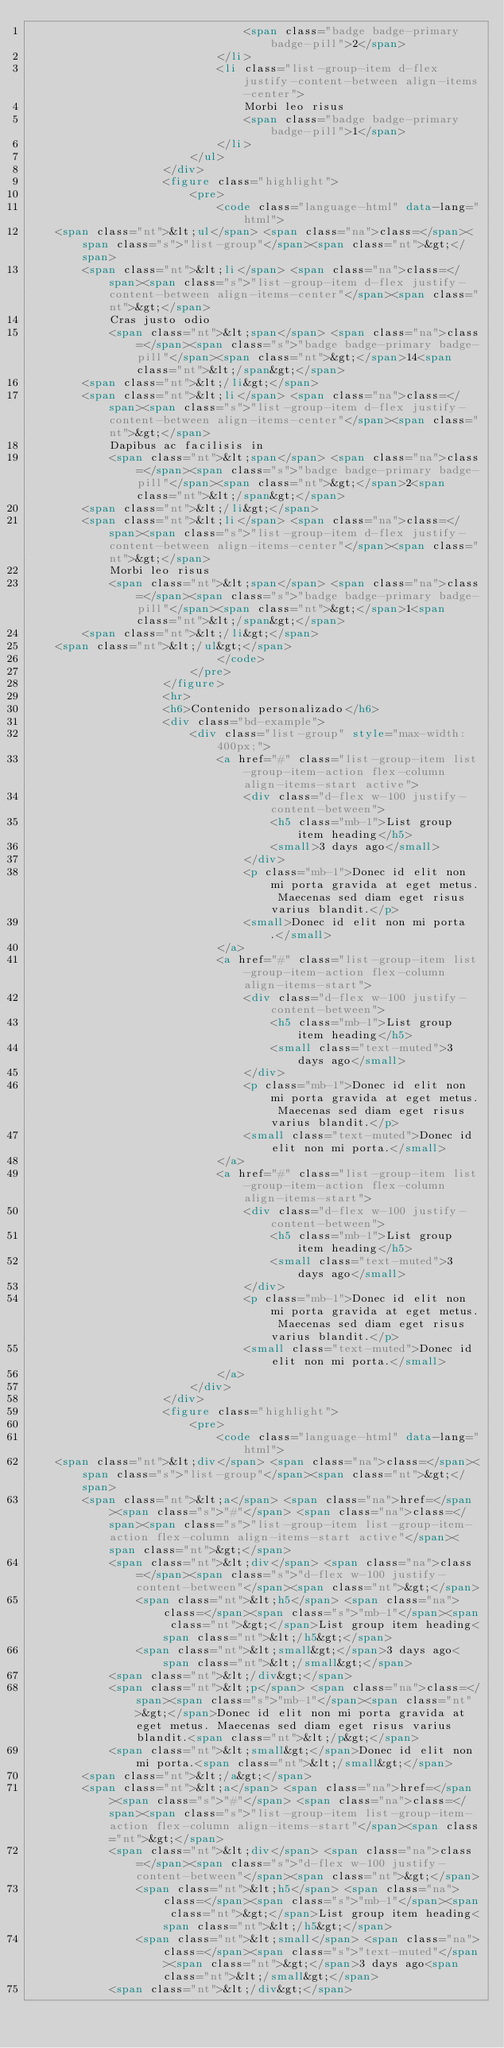<code> <loc_0><loc_0><loc_500><loc_500><_HTML_>                                <span class="badge badge-primary badge-pill">2</span>
                            </li>
                            <li class="list-group-item d-flex justify-content-between align-items-center">
                                Morbi leo risus
                                <span class="badge badge-primary badge-pill">1</span>
                            </li>
                        </ul>
                    </div>
                    <figure class="highlight">
                        <pre>
                            <code class="language-html" data-lang="html">
    <span class="nt">&lt;ul</span> <span class="na">class=</span><span class="s">"list-group"</span><span class="nt">&gt;</span>
        <span class="nt">&lt;li</span> <span class="na">class=</span><span class="s">"list-group-item d-flex justify-content-between align-items-center"</span><span class="nt">&gt;</span>
            Cras justo odio
            <span class="nt">&lt;span</span> <span class="na">class=</span><span class="s">"badge badge-primary badge-pill"</span><span class="nt">&gt;</span>14<span class="nt">&lt;/span&gt;</span>
        <span class="nt">&lt;/li&gt;</span>
        <span class="nt">&lt;li</span> <span class="na">class=</span><span class="s">"list-group-item d-flex justify-content-between align-items-center"</span><span class="nt">&gt;</span>
            Dapibus ac facilisis in
            <span class="nt">&lt;span</span> <span class="na">class=</span><span class="s">"badge badge-primary badge-pill"</span><span class="nt">&gt;</span>2<span class="nt">&lt;/span&gt;</span>
        <span class="nt">&lt;/li&gt;</span>
        <span class="nt">&lt;li</span> <span class="na">class=</span><span class="s">"list-group-item d-flex justify-content-between align-items-center"</span><span class="nt">&gt;</span>
            Morbi leo risus
            <span class="nt">&lt;span</span> <span class="na">class=</span><span class="s">"badge badge-primary badge-pill"</span><span class="nt">&gt;</span>1<span class="nt">&lt;/span&gt;</span>
        <span class="nt">&lt;/li&gt;</span>
    <span class="nt">&lt;/ul&gt;</span>
                            </code>
                        </pre>
                    </figure>
                    <hr>
                    <h6>Contenido personalizado</h6>
                    <div class="bd-example">
                        <div class="list-group" style="max-width: 400px;">
                            <a href="#" class="list-group-item list-group-item-action flex-column align-items-start active">
                                <div class="d-flex w-100 justify-content-between">
                                    <h5 class="mb-1">List group item heading</h5>
                                    <small>3 days ago</small>
                                </div>
                                <p class="mb-1">Donec id elit non mi porta gravida at eget metus. Maecenas sed diam eget risus varius blandit.</p>
                                <small>Donec id elit non mi porta.</small>
                            </a>
                            <a href="#" class="list-group-item list-group-item-action flex-column align-items-start">
                                <div class="d-flex w-100 justify-content-between">
                                    <h5 class="mb-1">List group item heading</h5>
                                    <small class="text-muted">3 days ago</small>
                                </div>
                                <p class="mb-1">Donec id elit non mi porta gravida at eget metus. Maecenas sed diam eget risus varius blandit.</p>
                                <small class="text-muted">Donec id elit non mi porta.</small>
                            </a>
                            <a href="#" class="list-group-item list-group-item-action flex-column align-items-start">
                                <div class="d-flex w-100 justify-content-between">
                                    <h5 class="mb-1">List group item heading</h5>
                                    <small class="text-muted">3 days ago</small>
                                </div>
                                <p class="mb-1">Donec id elit non mi porta gravida at eget metus. Maecenas sed diam eget risus varius blandit.</p>
                                <small class="text-muted">Donec id elit non mi porta.</small>
                            </a>
                        </div>
                    </div>
                    <figure class="highlight">
                        <pre>
                            <code class="language-html" data-lang="html">
    <span class="nt">&lt;div</span> <span class="na">class=</span><span class="s">"list-group"</span><span class="nt">&gt;</span>
        <span class="nt">&lt;a</span> <span class="na">href=</span><span class="s">"#"</span> <span class="na">class=</span><span class="s">"list-group-item list-group-item-action flex-column align-items-start active"</span><span class="nt">&gt;</span>
            <span class="nt">&lt;div</span> <span class="na">class=</span><span class="s">"d-flex w-100 justify-content-between"</span><span class="nt">&gt;</span>
                <span class="nt">&lt;h5</span> <span class="na">class=</span><span class="s">"mb-1"</span><span class="nt">&gt;</span>List group item heading<span class="nt">&lt;/h5&gt;</span>
                <span class="nt">&lt;small&gt;</span>3 days ago<span class="nt">&lt;/small&gt;</span>
            <span class="nt">&lt;/div&gt;</span>
            <span class="nt">&lt;p</span> <span class="na">class=</span><span class="s">"mb-1"</span><span class="nt">&gt;</span>Donec id elit non mi porta gravida at eget metus. Maecenas sed diam eget risus varius blandit.<span class="nt">&lt;/p&gt;</span>
            <span class="nt">&lt;small&gt;</span>Donec id elit non mi porta.<span class="nt">&lt;/small&gt;</span>
        <span class="nt">&lt;/a&gt;</span>
        <span class="nt">&lt;a</span> <span class="na">href=</span><span class="s">"#"</span> <span class="na">class=</span><span class="s">"list-group-item list-group-item-action flex-column align-items-start"</span><span class="nt">&gt;</span>
            <span class="nt">&lt;div</span> <span class="na">class=</span><span class="s">"d-flex w-100 justify-content-between"</span><span class="nt">&gt;</span>
                <span class="nt">&lt;h5</span> <span class="na">class=</span><span class="s">"mb-1"</span><span class="nt">&gt;</span>List group item heading<span class="nt">&lt;/h5&gt;</span>
                <span class="nt">&lt;small</span> <span class="na">class=</span><span class="s">"text-muted"</span><span class="nt">&gt;</span>3 days ago<span class="nt">&lt;/small&gt;</span>
            <span class="nt">&lt;/div&gt;</span></code> 